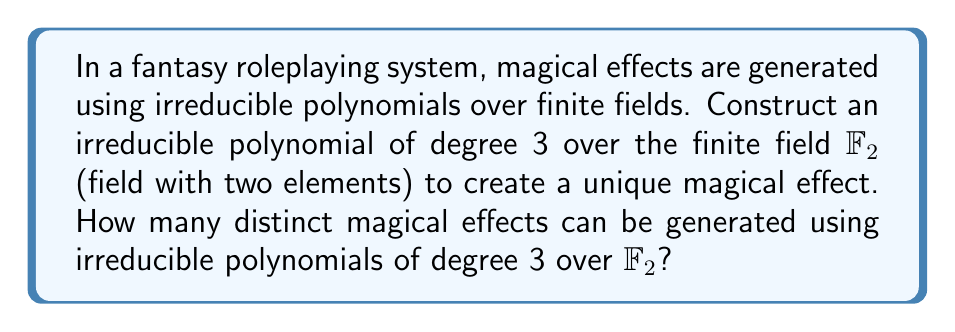Give your solution to this math problem. To solve this problem, we'll follow these steps:

1) First, let's recall that a polynomial of degree 3 over $\mathbb{F}_2$ has the general form:

   $f(x) = x^3 + ax^2 + bx + c$, where $a,b,c \in \mathbb{F}_2 = \{0,1\}$

2) To construct an irreducible polynomial, we need to ensure it has no roots in $\mathbb{F}_2$. We can check this by evaluating $f(0)$ and $f(1)$:

   $f(0) = c$
   $f(1) = 1 + a + b + c$

   For irreducibility, both of these must be non-zero in $\mathbb{F}_2$.

3) Given these conditions, we can deduce that $c$ must be 1, and $a + b$ must be 0 (so that $1 + a + b + 1 = 1$ in $\mathbb{F}_2$).

4) This leaves us with two possibilities for irreducible polynomials:

   $x^3 + x + 1$ and $x^3 + x^2 + 1$

5) To verify irreducibility, we can check that these polynomials don't factor over $\mathbb{F}_2[x]$.

6) Therefore, there are 2 distinct irreducible polynomials of degree 3 over $\mathbb{F}_2$, each generating a unique magical effect in our fantasy roleplaying system.

In the context of the narrative research for historical fiction, these two unique magical effects could represent different types of spells or enchantments in the game world, providing a mathematical basis for the magic system in the story.
Answer: 2 